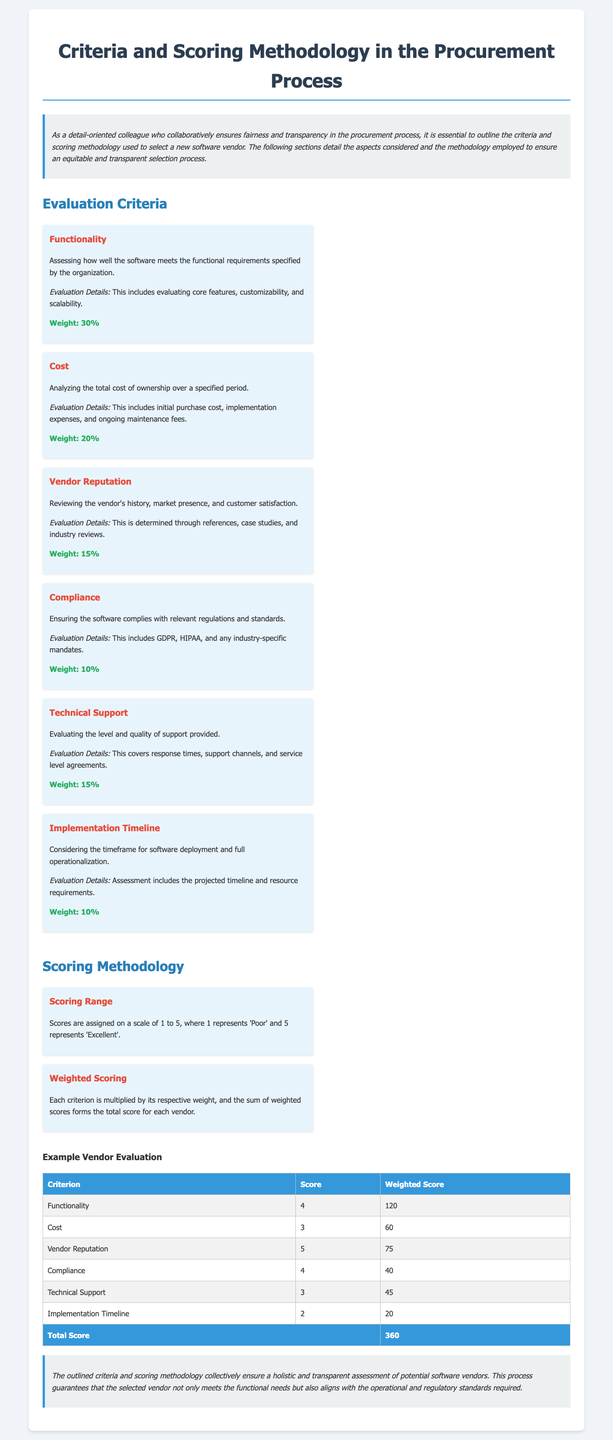What is the weight of the Functionality criterion? The weight is specified within the Evaluation Criteria section of the document as 30%.
Answer: 30% What scale is used for scoring? The scoring methodology mentions that scores are assigned on a scale of 1 to 5.
Answer: 1 to 5 How many criteria are listed in the evaluation? A count of the criteria can be done by reviewing the Evaluation Criteria section, which includes six criteria.
Answer: 6 What is the total score for the example vendor evaluation? The total score can be found in the example vendor evaluation table, which sums up to 360.
Answer: 360 What percentage weight does the Cost criterion carry? The document specifies the weight of the Cost criterion in the Evaluation Criteria as 20%.
Answer: 20% Which criterion has the maximum weight? By examining the weights assigned to each criterion, Functionality has the maximum weight of 30%.
Answer: Functionality How many points were assigned for the Vendor Reputation criterion? The table in the vendor evaluation details a score of 5 for the Vendor Reputation criterion.
Answer: 5 What does the Compliance criterion ensure? The Compliance criterion focuses on ensuring the software complies with relevant regulations and standards.
Answer: Compliance with regulations What type of document is this? The document is a declaration specifically outlining criteria and scoring methodology used in the procurement process.
Answer: Declaration 